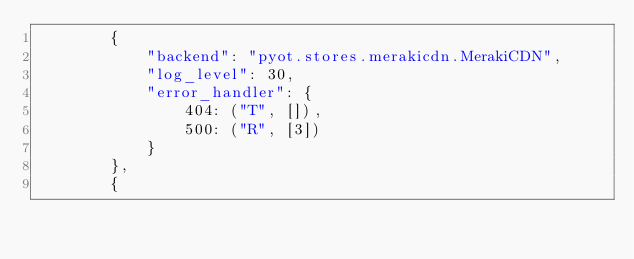<code> <loc_0><loc_0><loc_500><loc_500><_Python_>        {
            "backend": "pyot.stores.merakicdn.MerakiCDN",
            "log_level": 30,
            "error_handler": {
                404: ("T", []),
                500: ("R", [3])
            }
        },
        {</code> 